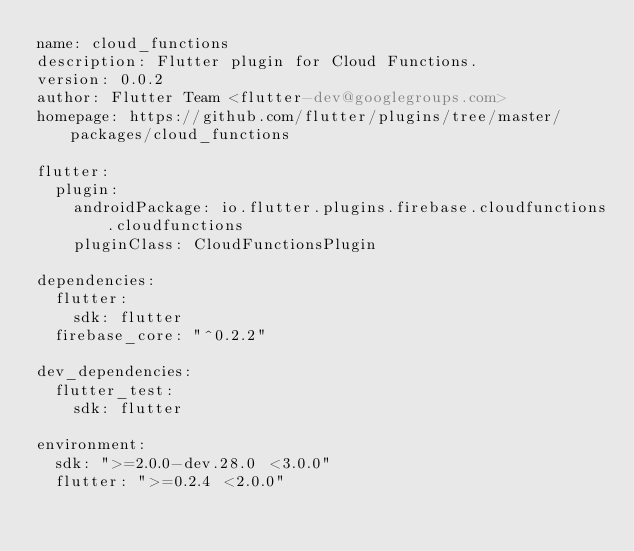Convert code to text. <code><loc_0><loc_0><loc_500><loc_500><_YAML_>name: cloud_functions
description: Flutter plugin for Cloud Functions.
version: 0.0.2
author: Flutter Team <flutter-dev@googlegroups.com>
homepage: https://github.com/flutter/plugins/tree/master/packages/cloud_functions

flutter:
  plugin:
    androidPackage: io.flutter.plugins.firebase.cloudfunctions.cloudfunctions
    pluginClass: CloudFunctionsPlugin

dependencies:
  flutter:
    sdk: flutter
  firebase_core: "^0.2.2"

dev_dependencies:
  flutter_test:
    sdk: flutter

environment:
  sdk: ">=2.0.0-dev.28.0 <3.0.0"
  flutter: ">=0.2.4 <2.0.0"
</code> 